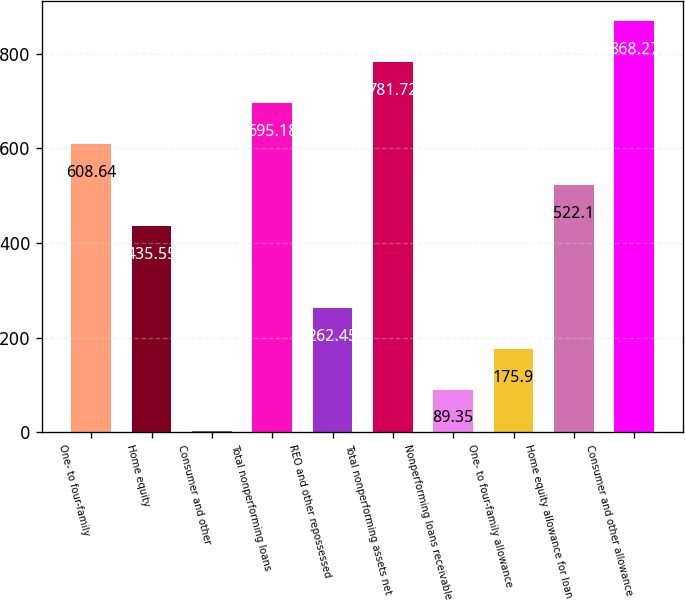Convert chart. <chart><loc_0><loc_0><loc_500><loc_500><bar_chart><fcel>One- to four-family<fcel>Home equity<fcel>Consumer and other<fcel>Total nonperforming loans<fcel>REO and other repossessed<fcel>Total nonperforming assets net<fcel>Nonperforming loans receivable<fcel>One- to four-family allowance<fcel>Home equity allowance for loan<fcel>Consumer and other allowance<nl><fcel>608.64<fcel>435.55<fcel>2.8<fcel>695.18<fcel>262.45<fcel>781.72<fcel>89.35<fcel>175.9<fcel>522.1<fcel>868.27<nl></chart> 